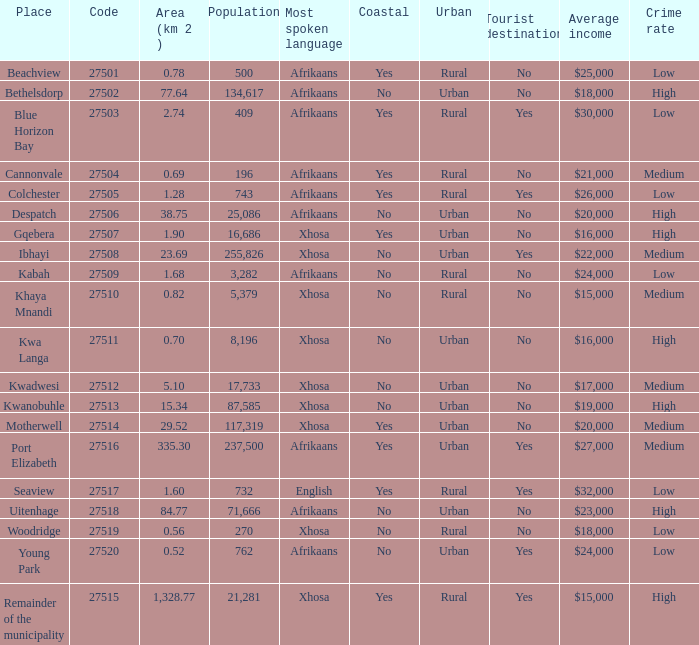What is the total number of area listed for cannonvale with a population less than 409? 1.0. 